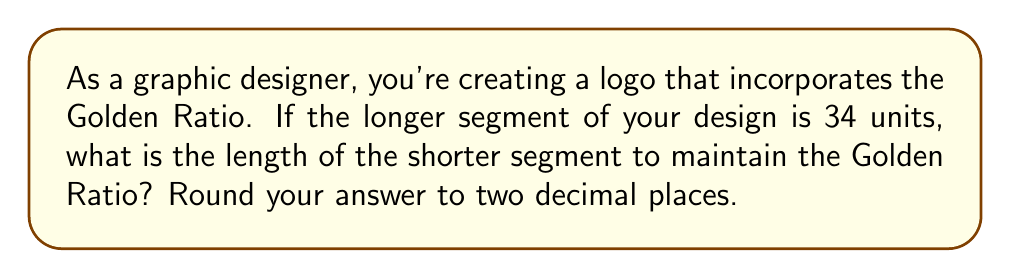Can you answer this question? To solve this problem, we need to follow these steps:

1. Recall the definition of the Golden Ratio:
   The Golden Ratio, often denoted by φ (phi), is approximately equal to 1.618033988749895...

2. The Golden Ratio is defined as the ratio of the longer segment (a) to the shorter segment (b):
   $$ \phi = \frac{a}{b} $$

3. We're given that the longer segment (a) is 34 units. Let's call the shorter segment x. We can set up the equation:
   $$ \phi = \frac{34}{x} $$

4. Substitute the value of φ:
   $$ 1.618033988749895... = \frac{34}{x} $$

5. Solve for x:
   $$ x = \frac{34}{1.618033988749895...} $$

6. Use a calculator to divide:
   $$ x ≈ 21.01246117974981... $$

7. Round to two decimal places:
   $$ x ≈ 21.01 $$

Therefore, the length of the shorter segment should be approximately 21.01 units to maintain the Golden Ratio with the longer segment of 34 units.
Answer: 21.01 units 